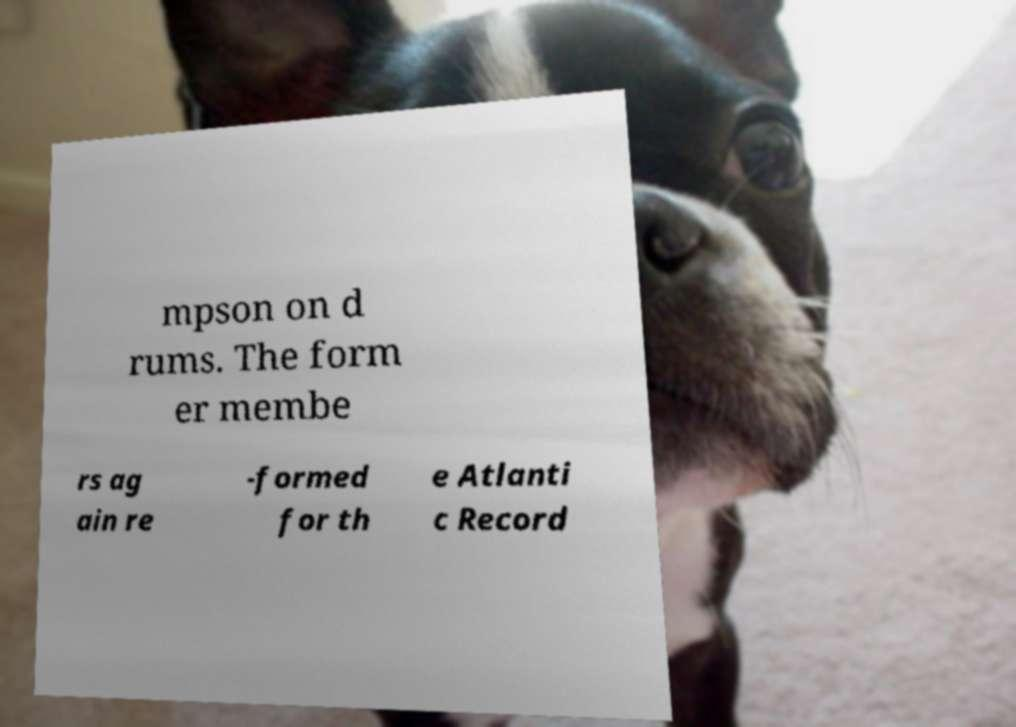What messages or text are displayed in this image? I need them in a readable, typed format. mpson on d rums. The form er membe rs ag ain re -formed for th e Atlanti c Record 